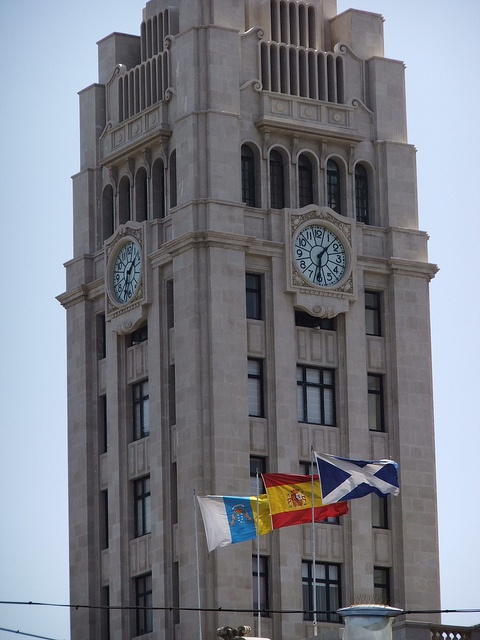Describe the objects in this image and their specific colors. I can see clock in darkgray, gray, and black tones and clock in darkgray, gray, and black tones in this image. 